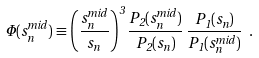Convert formula to latex. <formula><loc_0><loc_0><loc_500><loc_500>\Phi ( s ^ { m i d } _ { n } ) \equiv \left ( \frac { s ^ { m i d } _ { n } } { s _ { n } } \right ) ^ { 3 } \frac { P _ { 2 } ( s ^ { m i d } _ { n } ) } { P _ { 2 } ( s _ { n } ) } \, \frac { P _ { 1 } ( s _ { n } ) } { P _ { 1 } ( s ^ { m i d } _ { n } ) } \ .</formula> 